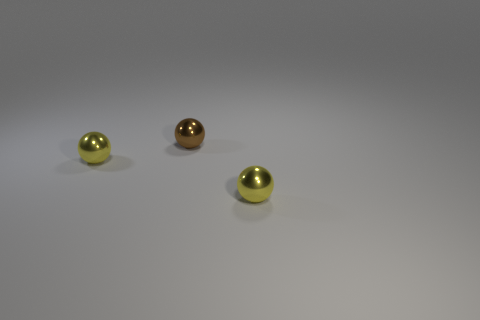Subtract all yellow spheres. How many spheres are left? 1 Add 1 small cyan things. How many objects exist? 4 Subtract all cyan blocks. How many yellow balls are left? 2 Subtract 2 balls. How many balls are left? 1 Subtract all yellow balls. How many balls are left? 1 Add 1 tiny objects. How many tiny objects exist? 4 Subtract 0 purple cylinders. How many objects are left? 3 Subtract all red spheres. Subtract all yellow cubes. How many spheres are left? 3 Subtract all brown spheres. Subtract all big matte objects. How many objects are left? 2 Add 3 yellow metal spheres. How many yellow metal spheres are left? 5 